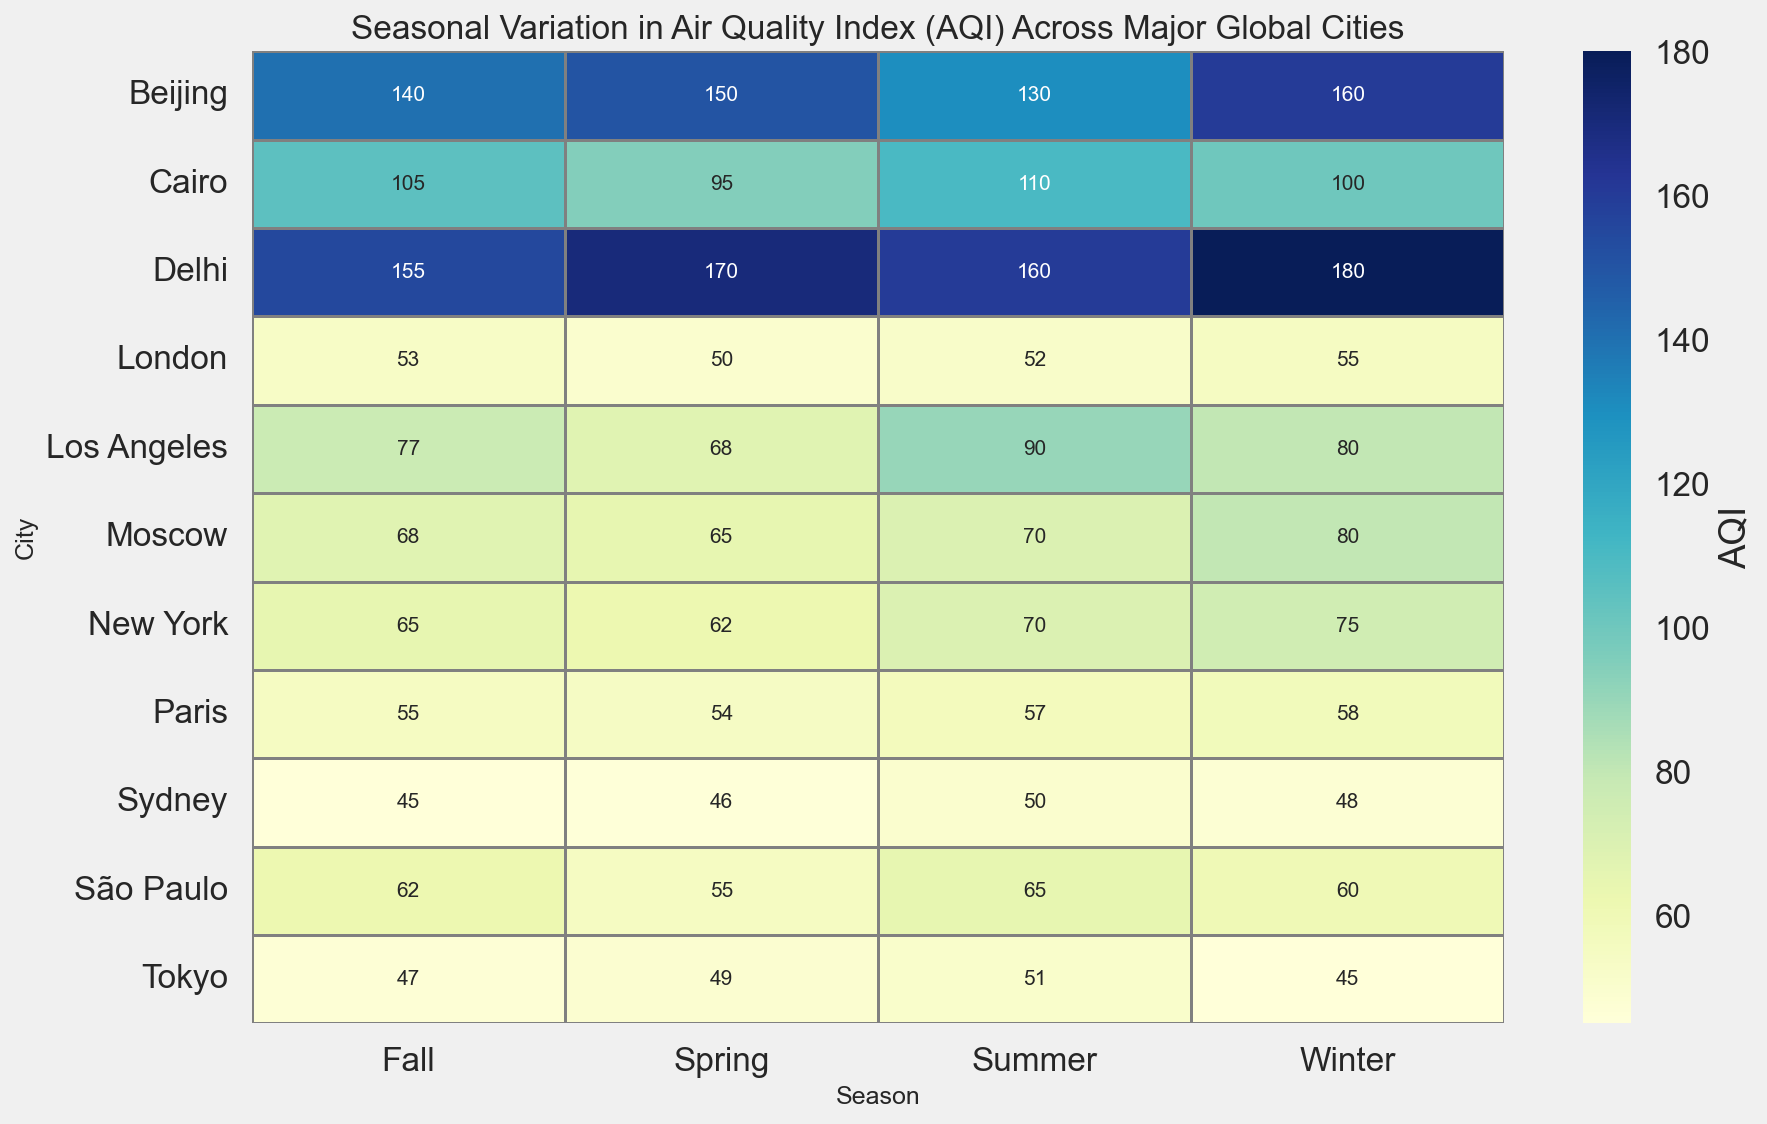Which city has the highest AQI in Summer? Look at the summer column to identify the highest value. Beijing (130), Los Angeles (90), and Delhi (160) have the highest AQI values, but Delhi's 160 is the highest among them.
Answer: Delhi Compare the Spring AQI of London and Paris. Which city has a lower AQI? Look at the AQI values for Spring in the rows corresponding to London and Paris. London has an AQI of 50, while Paris has an AQI of 54.
Answer: London What's the difference between the highest and lowest AQI values in Fall? Identify the highest and lowest AQI values in the Fall column. Delhi has the highest (155) and Sydney has the lowest (45). The difference is 155 - 45 = 110.
Answer: 110 Which city has the most consistent AQI value across all seasons (i.e., smallest range) and what are the AQI values? Calculate the range (max - min) of AQI values for each city. Tokyo's values are 45, 49, 51, 47, so the range is 51 - 45 = 6, which is the smallest range among all cities.
Answer: Tokyo, 45, 49, 51, 47 What is the average AQI for New York? Sum the AQI values for New York across all seasons (75, 62, 70, 65) and divide by the number of seasons (4): (75 + 62 + 70 + 65) / 4 = 272 / 4 = 68.
Answer: 68 Which season generally has the lowest AQI values across all cities, if any? Compare the AQI values across all seasons. Generally, Spring exhibits the lowest values across several cities (e.g., London: 50, Paris: 54, Tokyo: 49, Sydney: 46).
Answer: Spring Which city shows the largest seasonal AQI variation in Winter and what is this variation? Identify the AQI values for winter across cities and calculate the range. Delhi has the highest value in Winter (180), and Tokyo has the lowest (45), the variation is 180 - 45 = 135.
Answer: Delhi, 135 Does Moscow have a higher AQI in Summer or Winter? Compare the AQI values for Summer (70) and Winter (80) in Moscow's row. 80 is higher than 70.
Answer: Winter 